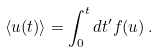Convert formula to latex. <formula><loc_0><loc_0><loc_500><loc_500>\langle u ( t ) \rangle = \int _ { 0 } ^ { t } d t ^ { \prime } f ( u ) \, .</formula> 